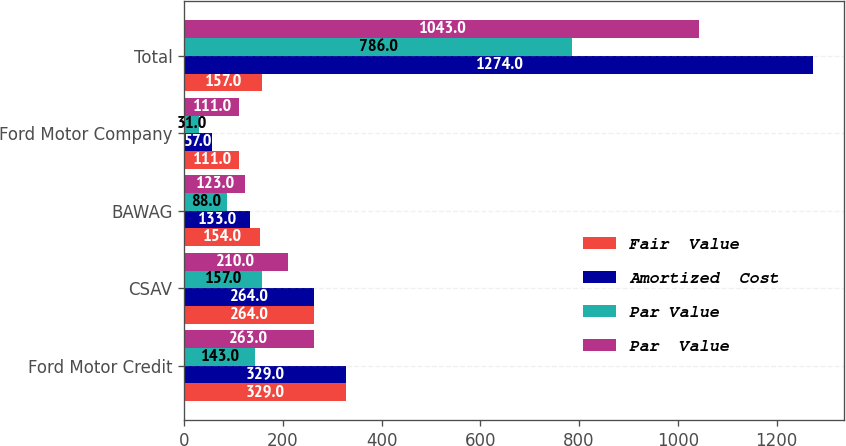Convert chart. <chart><loc_0><loc_0><loc_500><loc_500><stacked_bar_chart><ecel><fcel>Ford Motor Credit<fcel>CSAV<fcel>BAWAG<fcel>Ford Motor Company<fcel>Total<nl><fcel>Fair  Value<fcel>329<fcel>264<fcel>154<fcel>111<fcel>157<nl><fcel>Amortized  Cost<fcel>329<fcel>264<fcel>133<fcel>57<fcel>1274<nl><fcel>Par Value<fcel>143<fcel>157<fcel>88<fcel>31<fcel>786<nl><fcel>Par  Value<fcel>263<fcel>210<fcel>123<fcel>111<fcel>1043<nl></chart> 